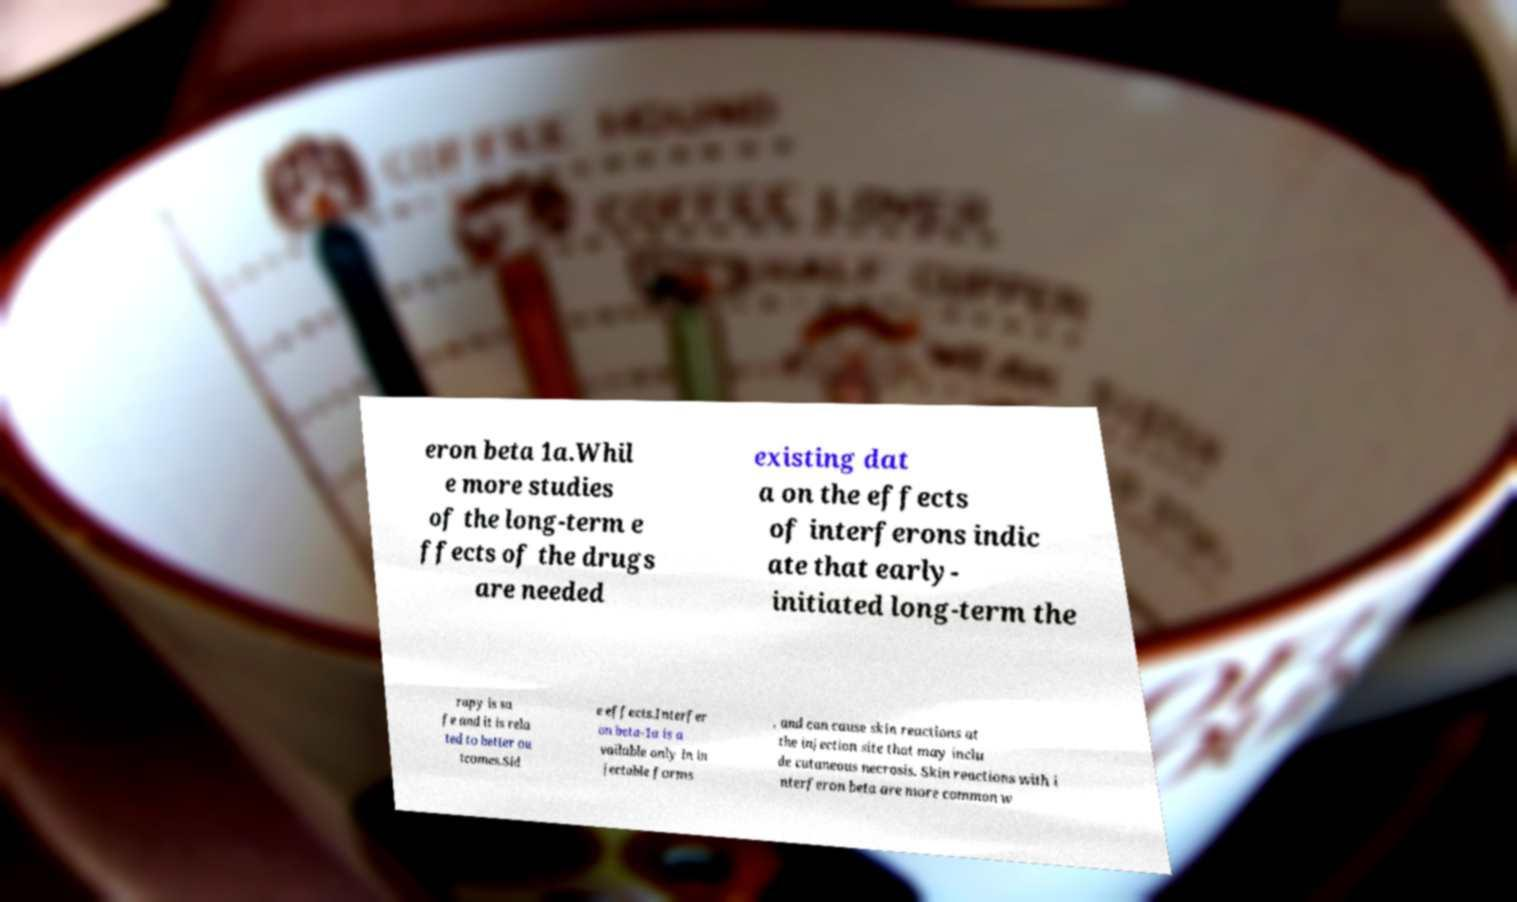What messages or text are displayed in this image? I need them in a readable, typed format. eron beta 1a.Whil e more studies of the long-term e ffects of the drugs are needed existing dat a on the effects of interferons indic ate that early- initiated long-term the rapy is sa fe and it is rela ted to better ou tcomes.Sid e effects.Interfer on beta-1a is a vailable only in in jectable forms , and can cause skin reactions at the injection site that may inclu de cutaneous necrosis. Skin reactions with i nterferon beta are more common w 